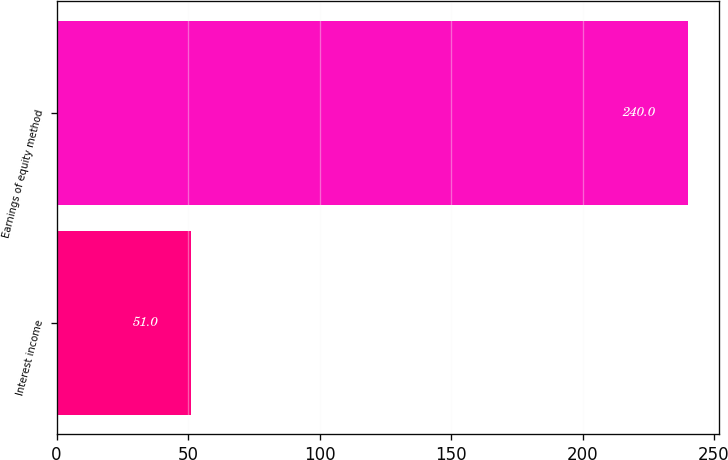<chart> <loc_0><loc_0><loc_500><loc_500><bar_chart><fcel>Interest income<fcel>Earnings of equity method<nl><fcel>51<fcel>240<nl></chart> 